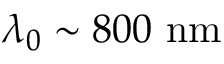Convert formula to latex. <formula><loc_0><loc_0><loc_500><loc_500>\lambda _ { 0 } \sim 8 0 0 \ n m</formula> 